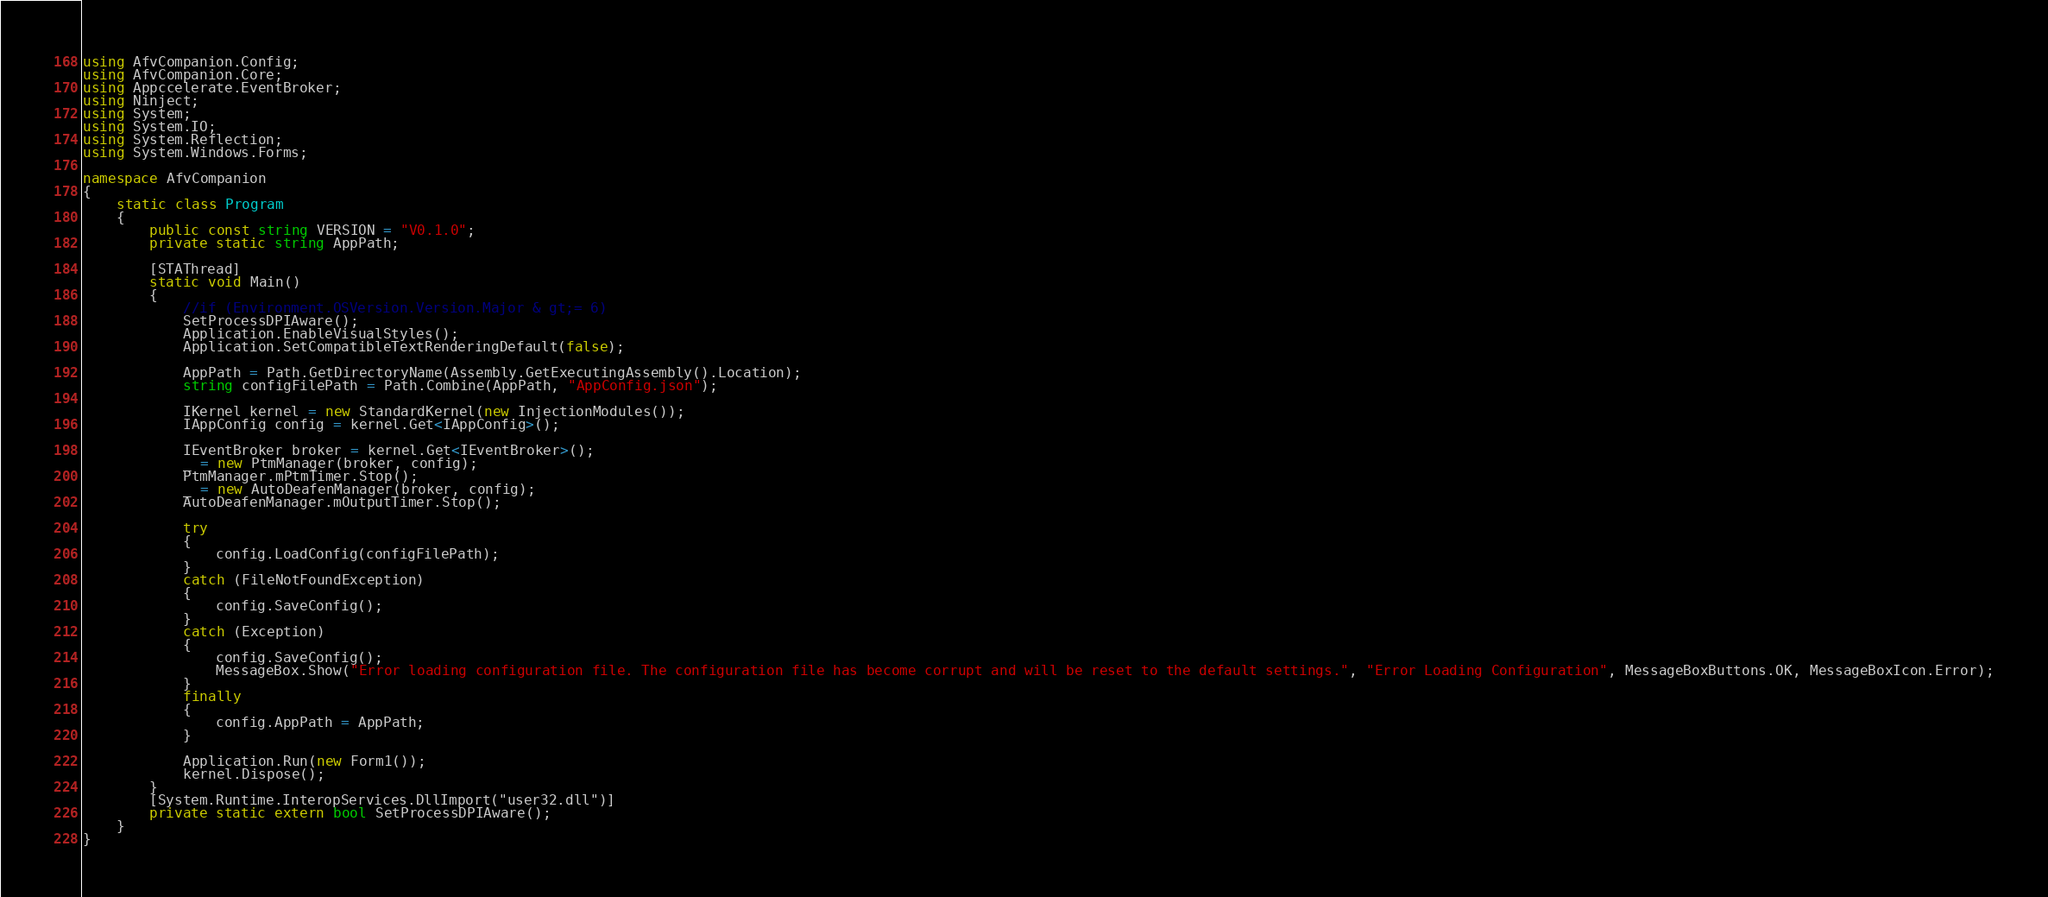Convert code to text. <code><loc_0><loc_0><loc_500><loc_500><_C#_>using AfvCompanion.Config;
using AfvCompanion.Core;
using Appccelerate.EventBroker;
using Ninject;
using System;
using System.IO;
using System.Reflection;
using System.Windows.Forms;

namespace AfvCompanion
{
    static class Program
    {
        public const string VERSION = "V0.1.0";
        private static string AppPath;

        [STAThread]
        static void Main()
        {
            //if (Environment.OSVersion.Version.Major & gt;= 6)
            SetProcessDPIAware();
            Application.EnableVisualStyles();
            Application.SetCompatibleTextRenderingDefault(false);

            AppPath = Path.GetDirectoryName(Assembly.GetExecutingAssembly().Location);
            string configFilePath = Path.Combine(AppPath, "AppConfig.json");

            IKernel kernel = new StandardKernel(new InjectionModules());
            IAppConfig config = kernel.Get<IAppConfig>();

            IEventBroker broker = kernel.Get<IEventBroker>();
            _ = new PtmManager(broker, config);
            PtmManager.mPtmTimer.Stop();
            _ = new AutoDeafenManager(broker, config);
            AutoDeafenManager.mOutputTimer.Stop();

            try
            {
                config.LoadConfig(configFilePath);
            }
            catch (FileNotFoundException)
            {
                config.SaveConfig();
            }
            catch (Exception)
            {
                config.SaveConfig();
                MessageBox.Show("Error loading configuration file. The configuration file has become corrupt and will be reset to the default settings.", "Error Loading Configuration", MessageBoxButtons.OK, MessageBoxIcon.Error);
            }
            finally
            {
                config.AppPath = AppPath;
            }

            Application.Run(new Form1());
            kernel.Dispose();
        }
        [System.Runtime.InteropServices.DllImport("user32.dll")]
        private static extern bool SetProcessDPIAware();
    }
}
</code> 